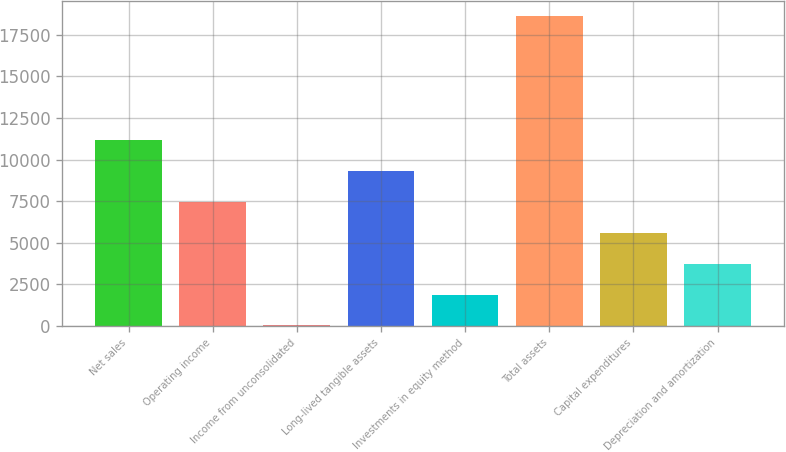Convert chart. <chart><loc_0><loc_0><loc_500><loc_500><bar_chart><fcel>Net sales<fcel>Operating income<fcel>Income from unconsolidated<fcel>Long-lived tangible assets<fcel>Investments in equity method<fcel>Total assets<fcel>Capital expenditures<fcel>Depreciation and amortization<nl><fcel>11172.4<fcel>7457.34<fcel>27.3<fcel>9314.85<fcel>1884.81<fcel>18602.4<fcel>5599.83<fcel>3742.32<nl></chart> 